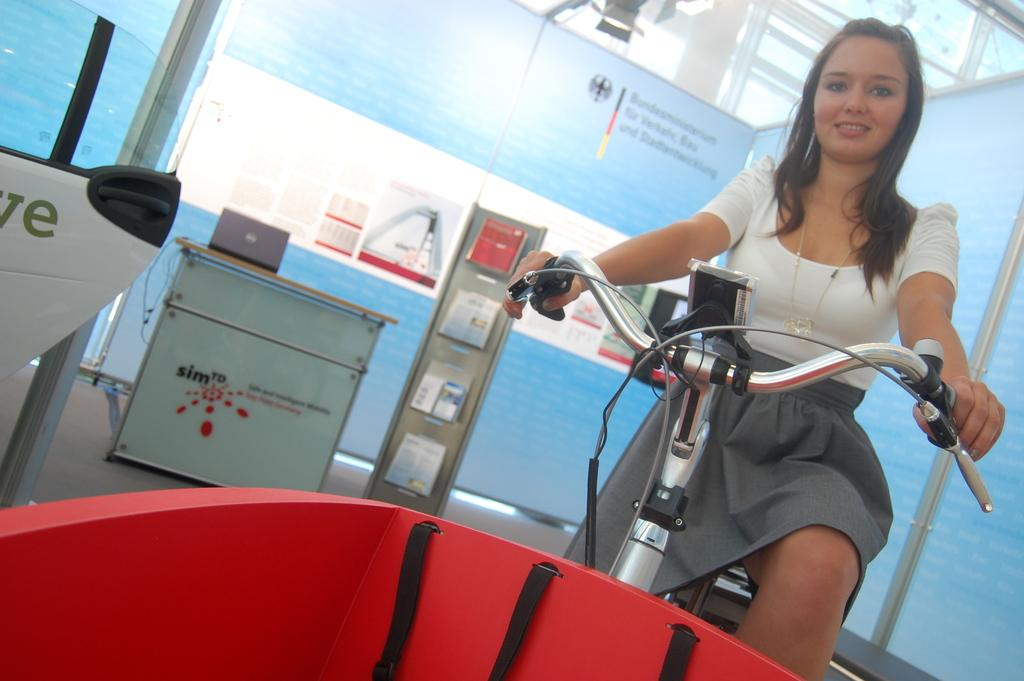What color is the object in the image? There is a red object in the image. Who is present in the image? A woman is present in the image. What is the woman doing? The woman is sitting on a bicycle and smiling. What else can be seen in the image? There are books, a table, posters, walls, and other objects visible in the image. What type of thunder can be heard in the image? There is no thunder present in the image, as it is a still image and cannot produce sound. 